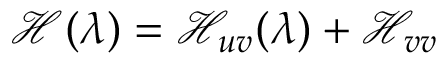<formula> <loc_0><loc_0><loc_500><loc_500>\mathcal { H } ( \lambda ) = \mathcal { H } _ { u v } ( \lambda ) + \mathcal { H } _ { v v }</formula> 